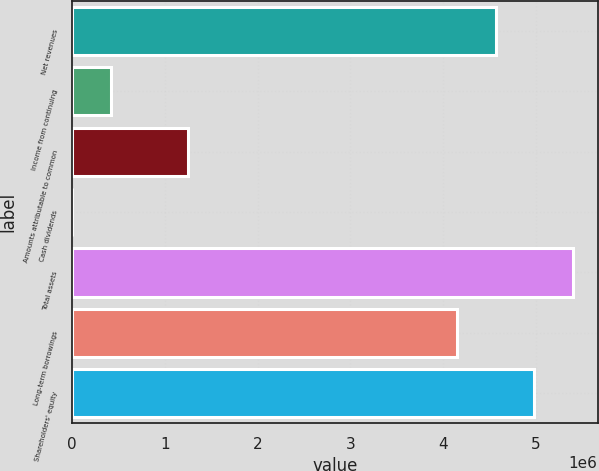Convert chart to OTSL. <chart><loc_0><loc_0><loc_500><loc_500><bar_chart><fcel>Net revenues<fcel>Income from continuing<fcel>Amounts attributable to common<fcel>Cash dividends<fcel>Total assets<fcel>Long-term borrowings<fcel>Shareholders' equity<nl><fcel>4.56631e+06<fcel>415121<fcel>1.24536e+06<fcel>1.36<fcel>5.39655e+06<fcel>4.15119e+06<fcel>4.98143e+06<nl></chart> 